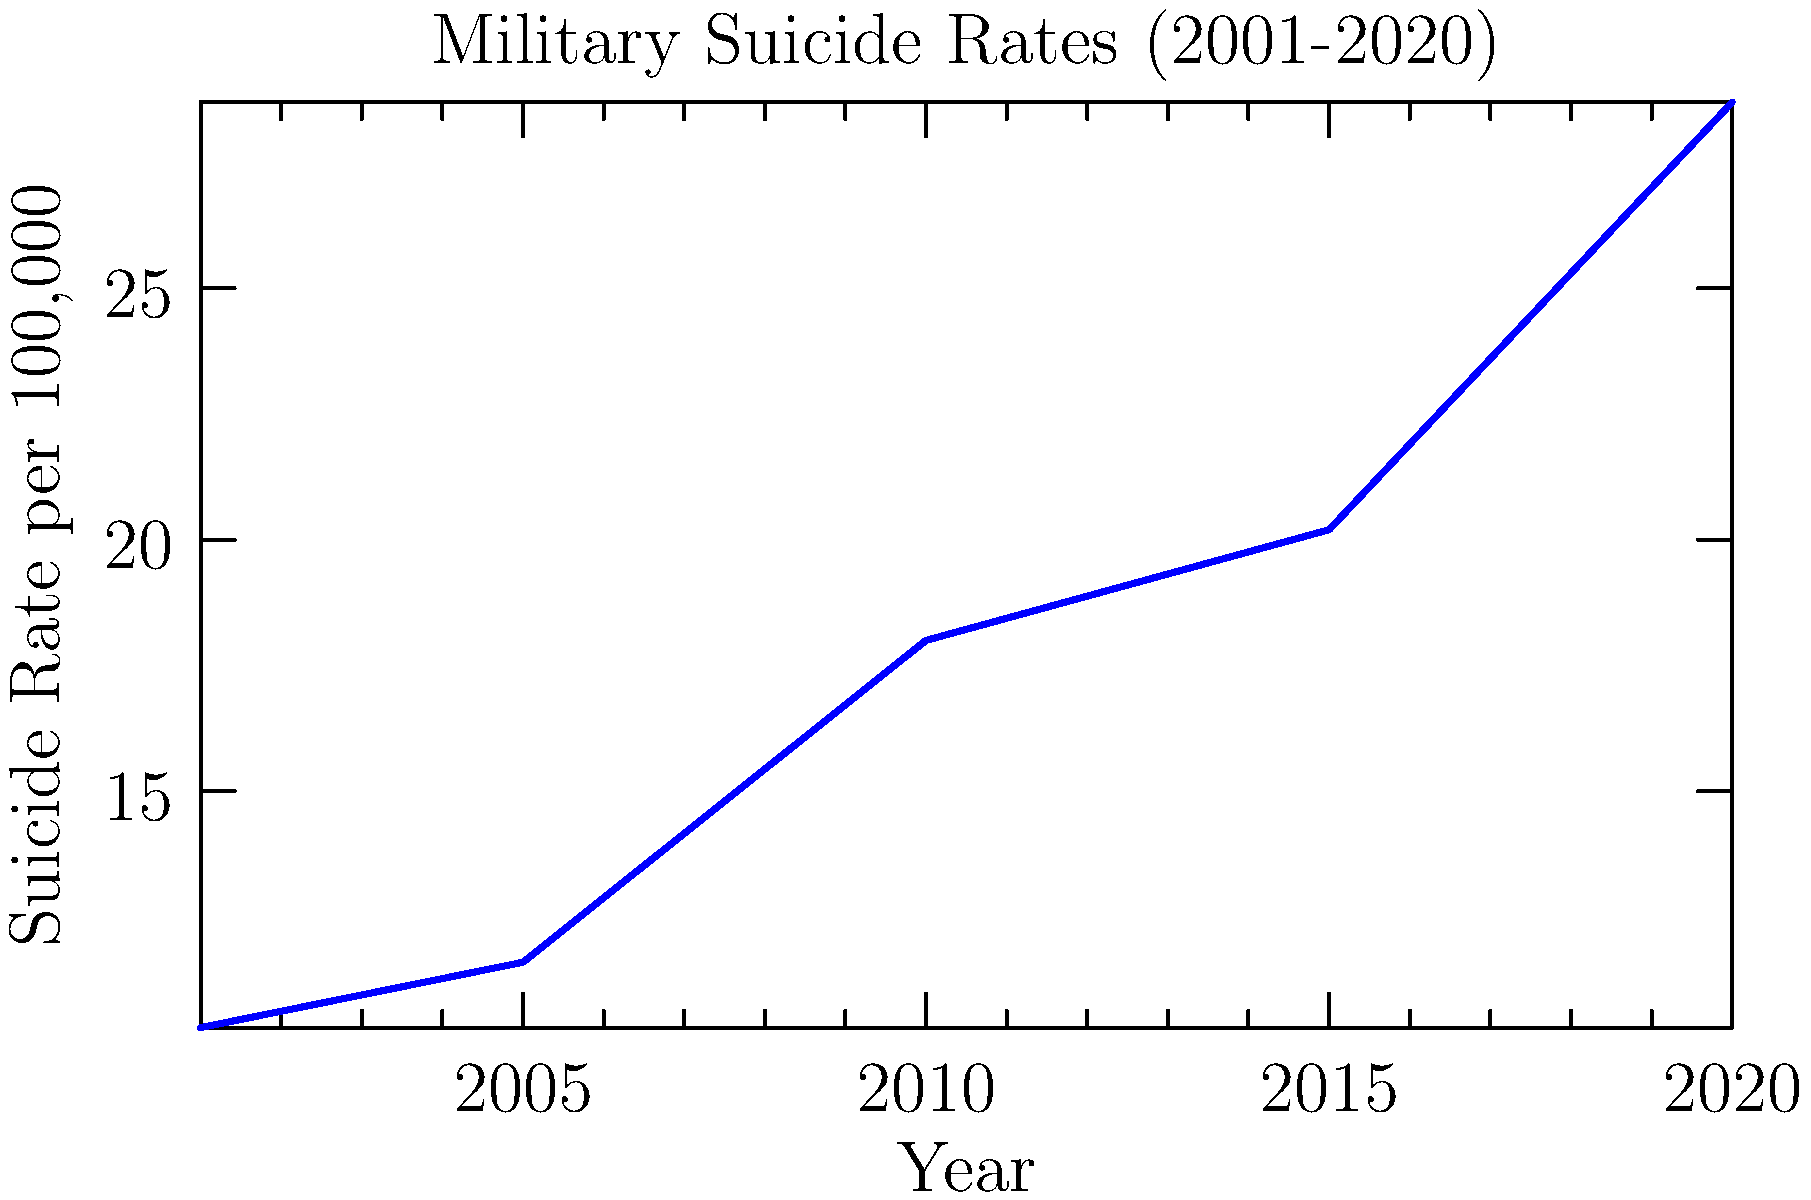Based on the line graph showing military suicide rates from 2001 to 2020, what was the approximate percentage increase in the suicide rate between 2001 and 2020? To calculate the percentage increase in the suicide rate between 2001 and 2020:

1. Identify the suicide rates:
   2001 rate: 10.3 per 100,000
   2020 rate: 28.7 per 100,000

2. Calculate the difference:
   28.7 - 10.3 = 18.4

3. Divide the difference by the initial value:
   18.4 / 10.3 ≈ 1.786

4. Convert to percentage:
   1.786 × 100 ≈ 178.6%

The suicide rate increased by approximately 179% between 2001 and 2020.
Answer: 179% 